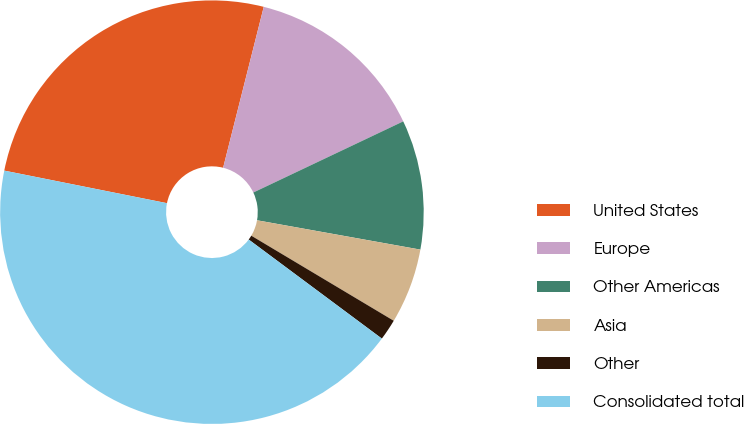Convert chart. <chart><loc_0><loc_0><loc_500><loc_500><pie_chart><fcel>United States<fcel>Europe<fcel>Other Americas<fcel>Asia<fcel>Other<fcel>Consolidated total<nl><fcel>25.79%<fcel>14.01%<fcel>9.88%<fcel>5.74%<fcel>1.61%<fcel>42.96%<nl></chart> 